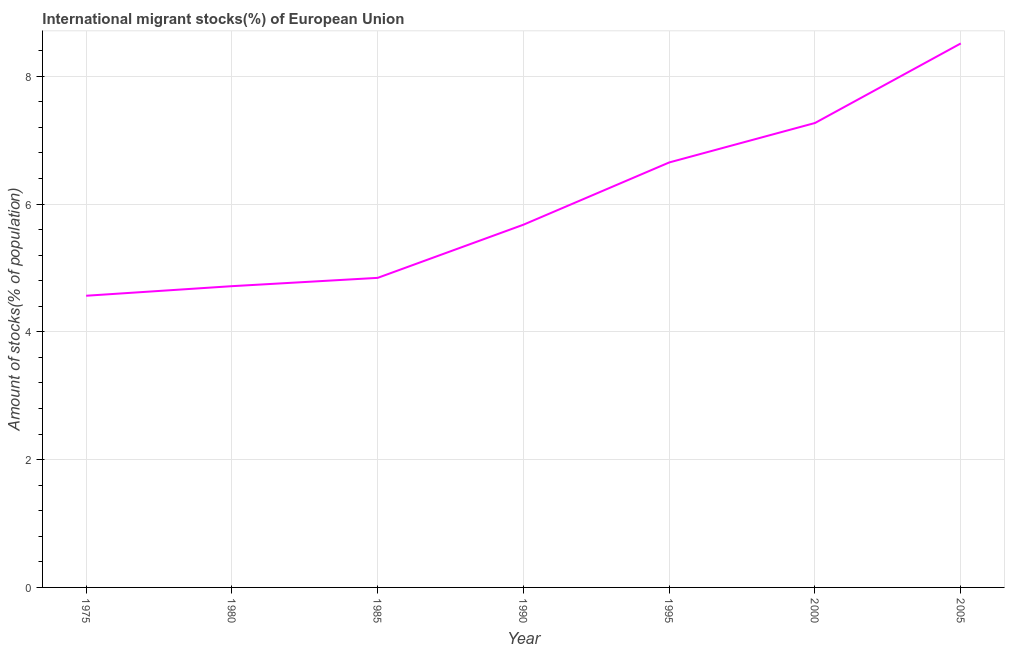What is the number of international migrant stocks in 1985?
Ensure brevity in your answer.  4.85. Across all years, what is the maximum number of international migrant stocks?
Your answer should be compact. 8.51. Across all years, what is the minimum number of international migrant stocks?
Your response must be concise. 4.57. In which year was the number of international migrant stocks minimum?
Your answer should be very brief. 1975. What is the sum of the number of international migrant stocks?
Your response must be concise. 42.24. What is the difference between the number of international migrant stocks in 1990 and 1995?
Your answer should be compact. -0.97. What is the average number of international migrant stocks per year?
Ensure brevity in your answer.  6.03. What is the median number of international migrant stocks?
Your answer should be compact. 5.68. In how many years, is the number of international migrant stocks greater than 3.6 %?
Offer a very short reply. 7. What is the ratio of the number of international migrant stocks in 1975 to that in 2000?
Ensure brevity in your answer.  0.63. Is the difference between the number of international migrant stocks in 1975 and 1985 greater than the difference between any two years?
Your response must be concise. No. What is the difference between the highest and the second highest number of international migrant stocks?
Offer a very short reply. 1.25. Is the sum of the number of international migrant stocks in 1990 and 2000 greater than the maximum number of international migrant stocks across all years?
Make the answer very short. Yes. What is the difference between the highest and the lowest number of international migrant stocks?
Ensure brevity in your answer.  3.95. Does the number of international migrant stocks monotonically increase over the years?
Keep it short and to the point. Yes. Does the graph contain any zero values?
Ensure brevity in your answer.  No. What is the title of the graph?
Make the answer very short. International migrant stocks(%) of European Union. What is the label or title of the X-axis?
Ensure brevity in your answer.  Year. What is the label or title of the Y-axis?
Give a very brief answer. Amount of stocks(% of population). What is the Amount of stocks(% of population) in 1975?
Your response must be concise. 4.57. What is the Amount of stocks(% of population) in 1980?
Offer a terse response. 4.72. What is the Amount of stocks(% of population) in 1985?
Your response must be concise. 4.85. What is the Amount of stocks(% of population) of 1990?
Your answer should be compact. 5.68. What is the Amount of stocks(% of population) in 1995?
Give a very brief answer. 6.65. What is the Amount of stocks(% of population) of 2000?
Keep it short and to the point. 7.27. What is the Amount of stocks(% of population) of 2005?
Provide a succinct answer. 8.51. What is the difference between the Amount of stocks(% of population) in 1975 and 1980?
Give a very brief answer. -0.15. What is the difference between the Amount of stocks(% of population) in 1975 and 1985?
Keep it short and to the point. -0.28. What is the difference between the Amount of stocks(% of population) in 1975 and 1990?
Provide a succinct answer. -1.11. What is the difference between the Amount of stocks(% of population) in 1975 and 1995?
Your answer should be compact. -2.09. What is the difference between the Amount of stocks(% of population) in 1975 and 2000?
Provide a succinct answer. -2.7. What is the difference between the Amount of stocks(% of population) in 1975 and 2005?
Keep it short and to the point. -3.95. What is the difference between the Amount of stocks(% of population) in 1980 and 1985?
Make the answer very short. -0.13. What is the difference between the Amount of stocks(% of population) in 1980 and 1990?
Your answer should be compact. -0.96. What is the difference between the Amount of stocks(% of population) in 1980 and 1995?
Your answer should be very brief. -1.94. What is the difference between the Amount of stocks(% of population) in 1980 and 2000?
Your response must be concise. -2.55. What is the difference between the Amount of stocks(% of population) in 1980 and 2005?
Make the answer very short. -3.8. What is the difference between the Amount of stocks(% of population) in 1985 and 1990?
Provide a short and direct response. -0.83. What is the difference between the Amount of stocks(% of population) in 1985 and 1995?
Provide a short and direct response. -1.81. What is the difference between the Amount of stocks(% of population) in 1985 and 2000?
Provide a short and direct response. -2.42. What is the difference between the Amount of stocks(% of population) in 1985 and 2005?
Give a very brief answer. -3.67. What is the difference between the Amount of stocks(% of population) in 1990 and 1995?
Ensure brevity in your answer.  -0.97. What is the difference between the Amount of stocks(% of population) in 1990 and 2000?
Offer a terse response. -1.59. What is the difference between the Amount of stocks(% of population) in 1990 and 2005?
Offer a terse response. -2.84. What is the difference between the Amount of stocks(% of population) in 1995 and 2000?
Give a very brief answer. -0.62. What is the difference between the Amount of stocks(% of population) in 1995 and 2005?
Your answer should be very brief. -1.86. What is the difference between the Amount of stocks(% of population) in 2000 and 2005?
Your answer should be very brief. -1.25. What is the ratio of the Amount of stocks(% of population) in 1975 to that in 1985?
Make the answer very short. 0.94. What is the ratio of the Amount of stocks(% of population) in 1975 to that in 1990?
Your response must be concise. 0.8. What is the ratio of the Amount of stocks(% of population) in 1975 to that in 1995?
Offer a very short reply. 0.69. What is the ratio of the Amount of stocks(% of population) in 1975 to that in 2000?
Your response must be concise. 0.63. What is the ratio of the Amount of stocks(% of population) in 1975 to that in 2005?
Give a very brief answer. 0.54. What is the ratio of the Amount of stocks(% of population) in 1980 to that in 1985?
Ensure brevity in your answer.  0.97. What is the ratio of the Amount of stocks(% of population) in 1980 to that in 1990?
Offer a terse response. 0.83. What is the ratio of the Amount of stocks(% of population) in 1980 to that in 1995?
Offer a terse response. 0.71. What is the ratio of the Amount of stocks(% of population) in 1980 to that in 2000?
Ensure brevity in your answer.  0.65. What is the ratio of the Amount of stocks(% of population) in 1980 to that in 2005?
Provide a short and direct response. 0.55. What is the ratio of the Amount of stocks(% of population) in 1985 to that in 1990?
Your response must be concise. 0.85. What is the ratio of the Amount of stocks(% of population) in 1985 to that in 1995?
Offer a terse response. 0.73. What is the ratio of the Amount of stocks(% of population) in 1985 to that in 2000?
Give a very brief answer. 0.67. What is the ratio of the Amount of stocks(% of population) in 1985 to that in 2005?
Offer a very short reply. 0.57. What is the ratio of the Amount of stocks(% of population) in 1990 to that in 1995?
Your response must be concise. 0.85. What is the ratio of the Amount of stocks(% of population) in 1990 to that in 2000?
Your response must be concise. 0.78. What is the ratio of the Amount of stocks(% of population) in 1990 to that in 2005?
Offer a terse response. 0.67. What is the ratio of the Amount of stocks(% of population) in 1995 to that in 2000?
Your answer should be very brief. 0.92. What is the ratio of the Amount of stocks(% of population) in 1995 to that in 2005?
Give a very brief answer. 0.78. What is the ratio of the Amount of stocks(% of population) in 2000 to that in 2005?
Offer a terse response. 0.85. 